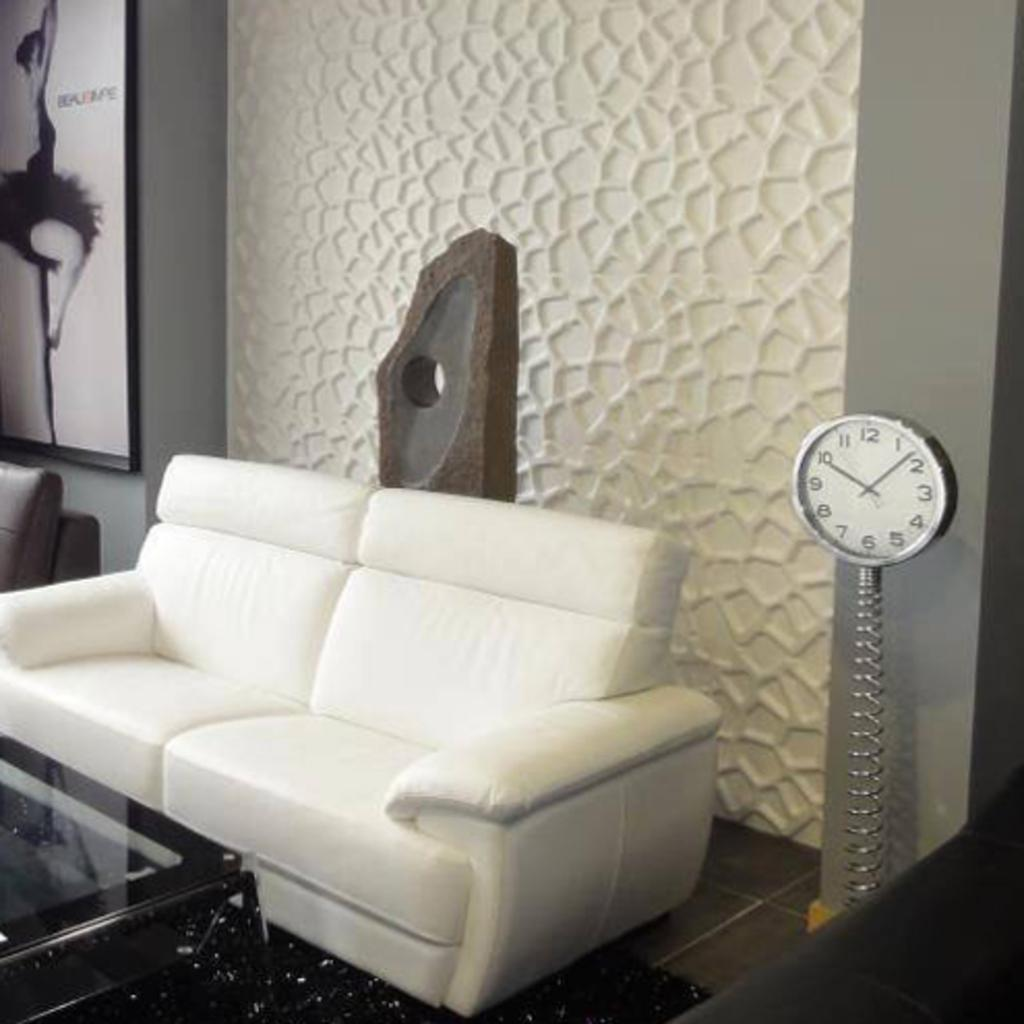<image>
Write a terse but informative summary of the picture. A clock has the number 12 at the top and 3 on the right side. 